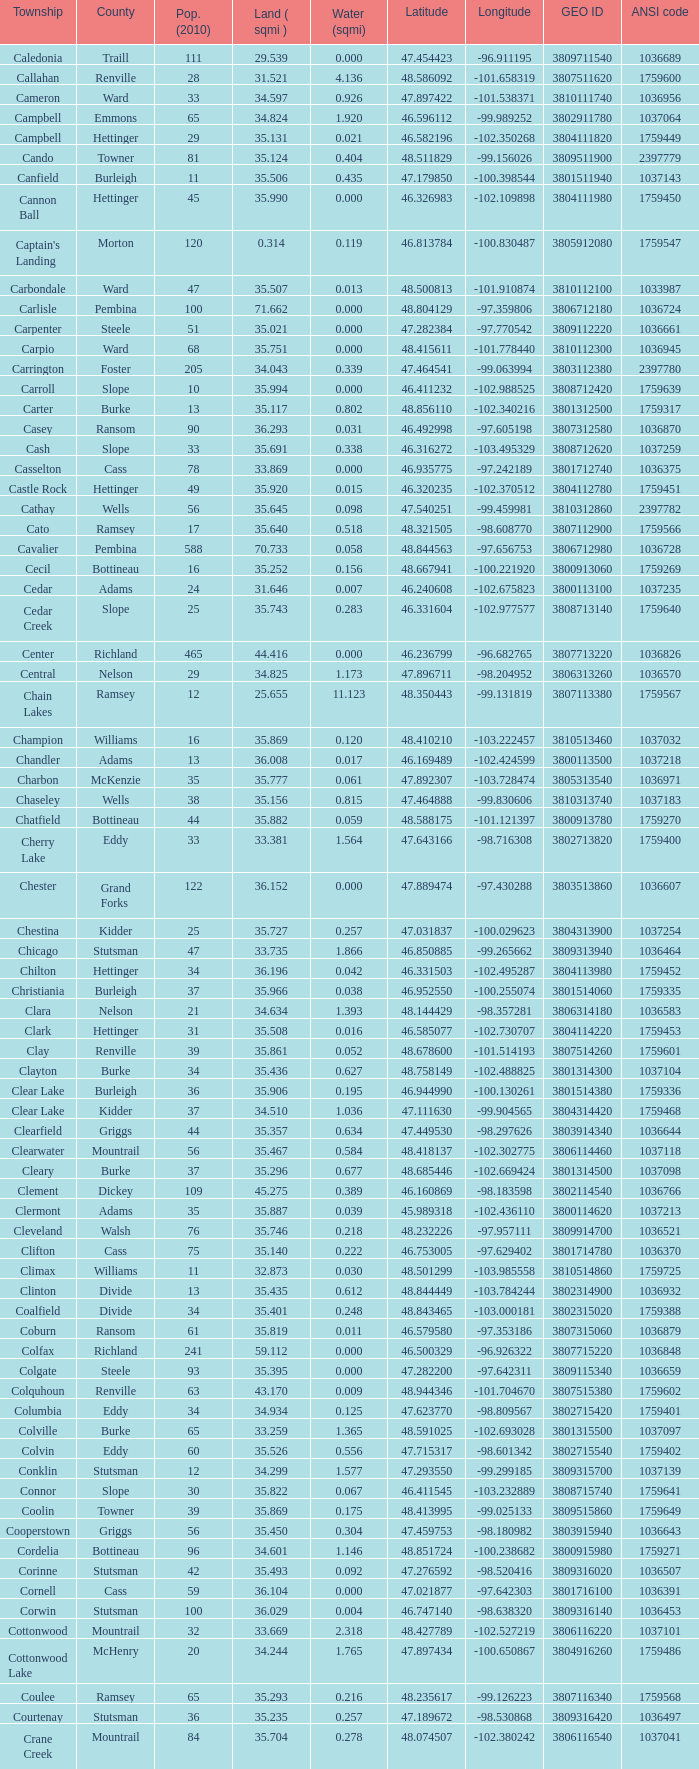What was the county with a longitude of -102.302775? Mountrail. 